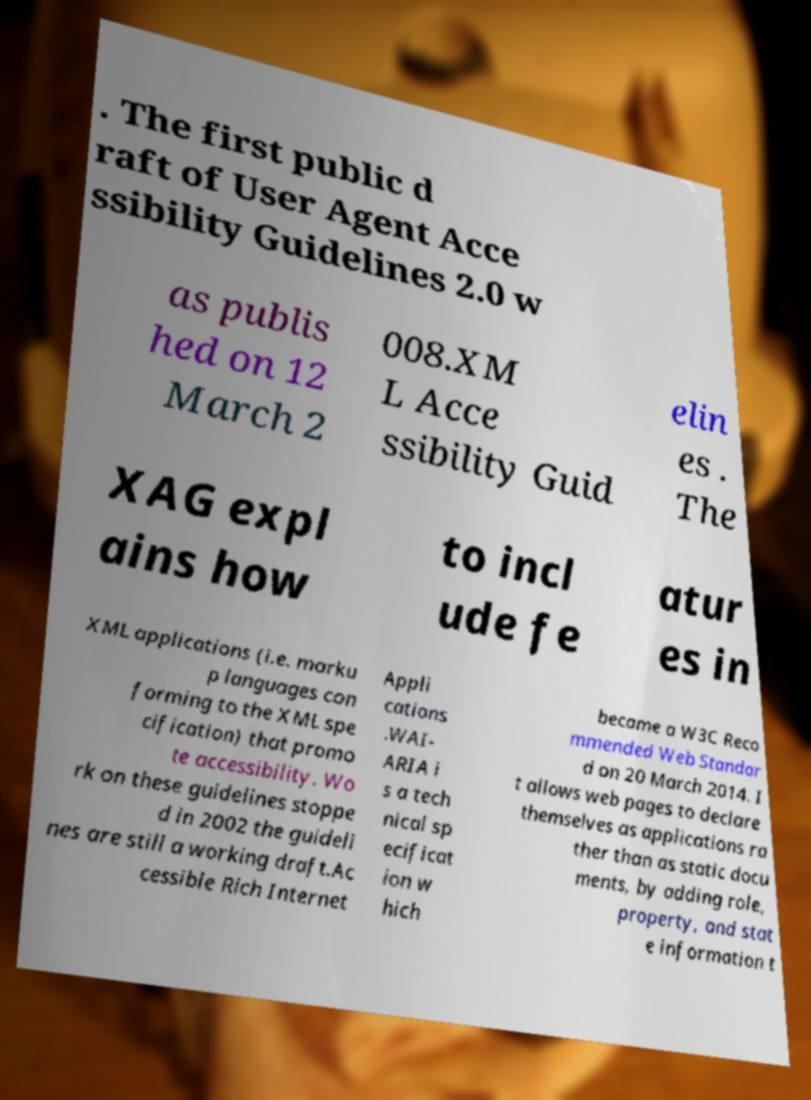Please identify and transcribe the text found in this image. . The first public d raft of User Agent Acce ssibility Guidelines 2.0 w as publis hed on 12 March 2 008.XM L Acce ssibility Guid elin es . The XAG expl ains how to incl ude fe atur es in XML applications (i.e. marku p languages con forming to the XML spe cification) that promo te accessibility. Wo rk on these guidelines stoppe d in 2002 the guideli nes are still a working draft.Ac cessible Rich Internet Appli cations .WAI- ARIA i s a tech nical sp ecificat ion w hich became a W3C Reco mmended Web Standar d on 20 March 2014. I t allows web pages to declare themselves as applications ra ther than as static docu ments, by adding role, property, and stat e information t 